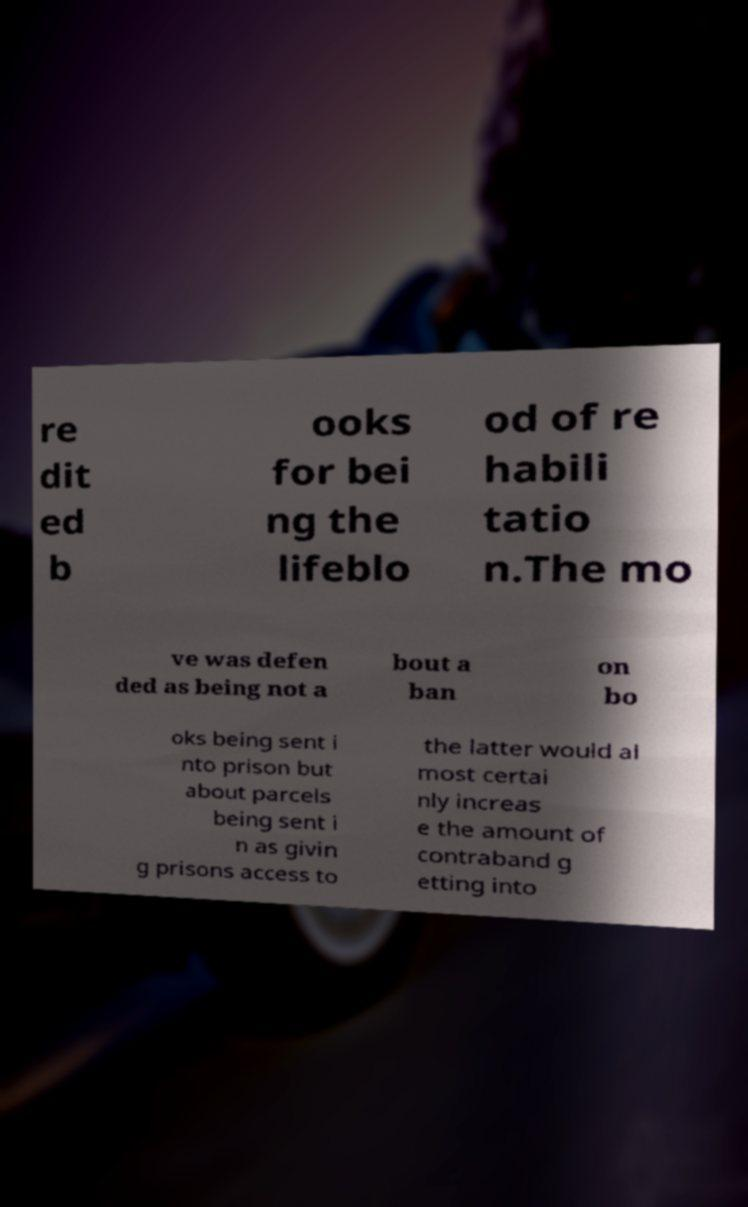Please identify and transcribe the text found in this image. re dit ed b ooks for bei ng the lifeblo od of re habili tatio n.The mo ve was defen ded as being not a bout a ban on bo oks being sent i nto prison but about parcels being sent i n as givin g prisons access to the latter would al most certai nly increas e the amount of contraband g etting into 